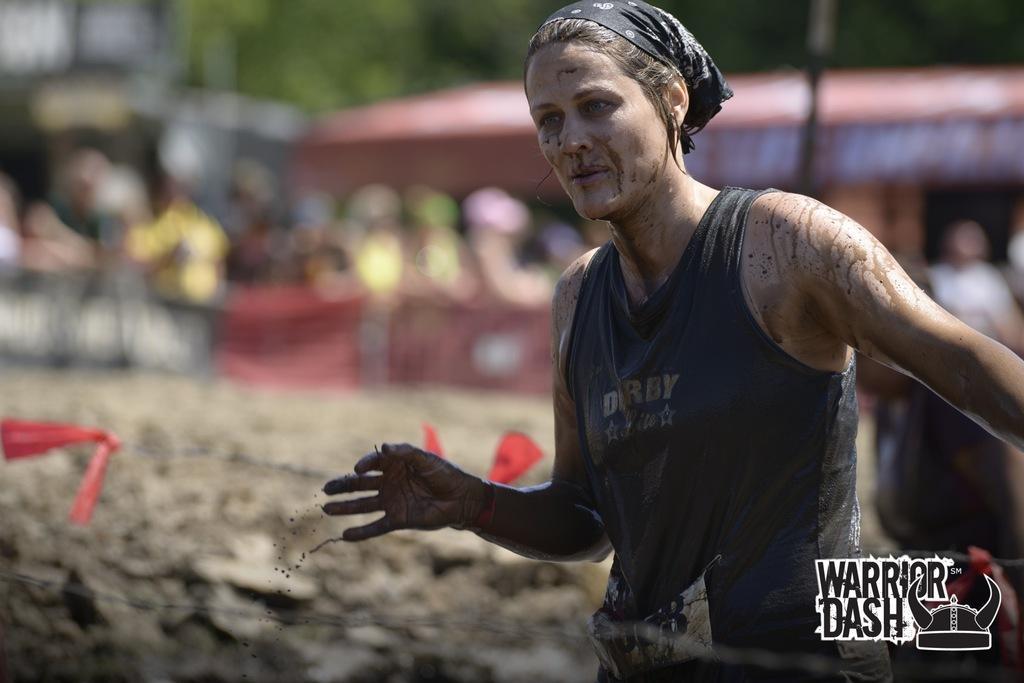Could you give a brief overview of what you see in this image? In the picture I can see a woman on the right side. She is wearing a black color top and there is a scarf on her head. I can see the metal wire at the bottom of the picture. 